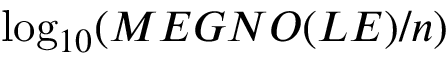<formula> <loc_0><loc_0><loc_500><loc_500>\log _ { 1 0 } ( M E G N O ( L E ) / n )</formula> 